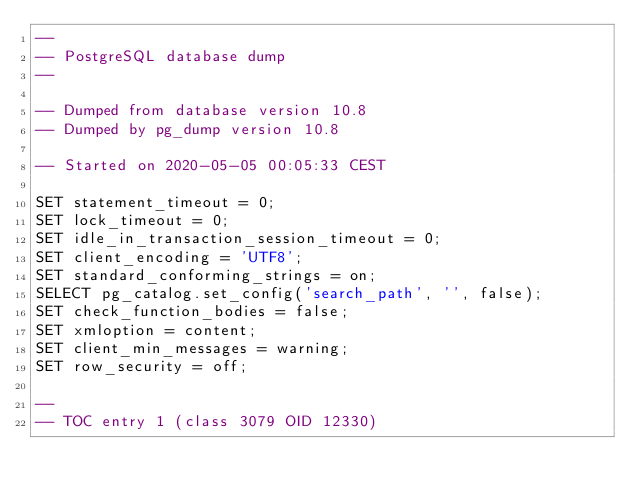Convert code to text. <code><loc_0><loc_0><loc_500><loc_500><_SQL_>--
-- PostgreSQL database dump
--

-- Dumped from database version 10.8
-- Dumped by pg_dump version 10.8

-- Started on 2020-05-05 00:05:33 CEST

SET statement_timeout = 0;
SET lock_timeout = 0;
SET idle_in_transaction_session_timeout = 0;
SET client_encoding = 'UTF8';
SET standard_conforming_strings = on;
SELECT pg_catalog.set_config('search_path', '', false);
SET check_function_bodies = false;
SET xmloption = content;
SET client_min_messages = warning;
SET row_security = off;

--
-- TOC entry 1 (class 3079 OID 12330)</code> 